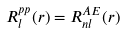Convert formula to latex. <formula><loc_0><loc_0><loc_500><loc_500>R _ { l } ^ { p p } ( r ) = R _ { n l } ^ { A E } ( r )</formula> 